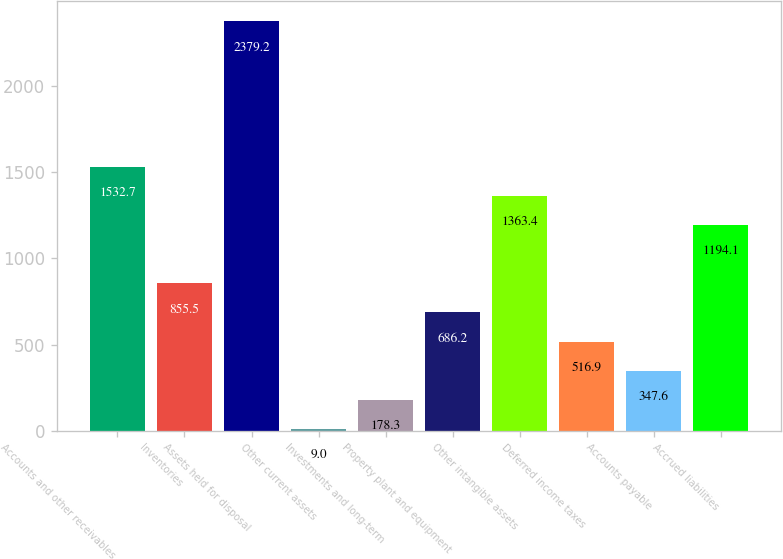Convert chart to OTSL. <chart><loc_0><loc_0><loc_500><loc_500><bar_chart><fcel>Accounts and other receivables<fcel>Inventories<fcel>Assets held for disposal<fcel>Other current assets<fcel>Investments and long-term<fcel>Property plant and equipment<fcel>Other intangible assets<fcel>Deferred income taxes<fcel>Accounts payable<fcel>Accrued liabilities<nl><fcel>1532.7<fcel>855.5<fcel>2379.2<fcel>9<fcel>178.3<fcel>686.2<fcel>1363.4<fcel>516.9<fcel>347.6<fcel>1194.1<nl></chart> 